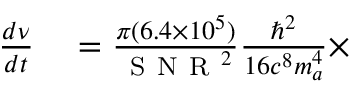<formula> <loc_0><loc_0><loc_500><loc_500>\begin{array} { r l } { \frac { d \nu } { d t } } & = \frac { \pi ( 6 . 4 \times 1 0 ^ { 5 } ) } { S N R ^ { 2 } } \frac { \hbar { ^ } { 2 } } { 1 6 c ^ { 8 } m _ { a } ^ { 4 } } \times } \end{array}</formula> 